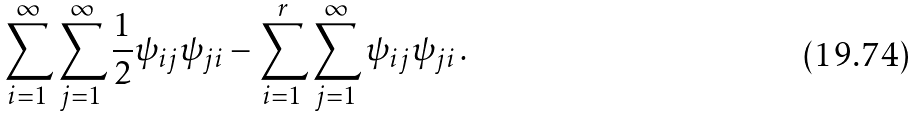<formula> <loc_0><loc_0><loc_500><loc_500>\sum _ { i = 1 } ^ { \infty } \sum _ { j = 1 } ^ { \infty } \frac { 1 } { 2 } \psi _ { i j } \psi _ { j i } - \sum _ { i = 1 } ^ { r } \sum _ { j = 1 } ^ { \infty } \psi _ { i j } \psi _ { j i } \, .</formula> 